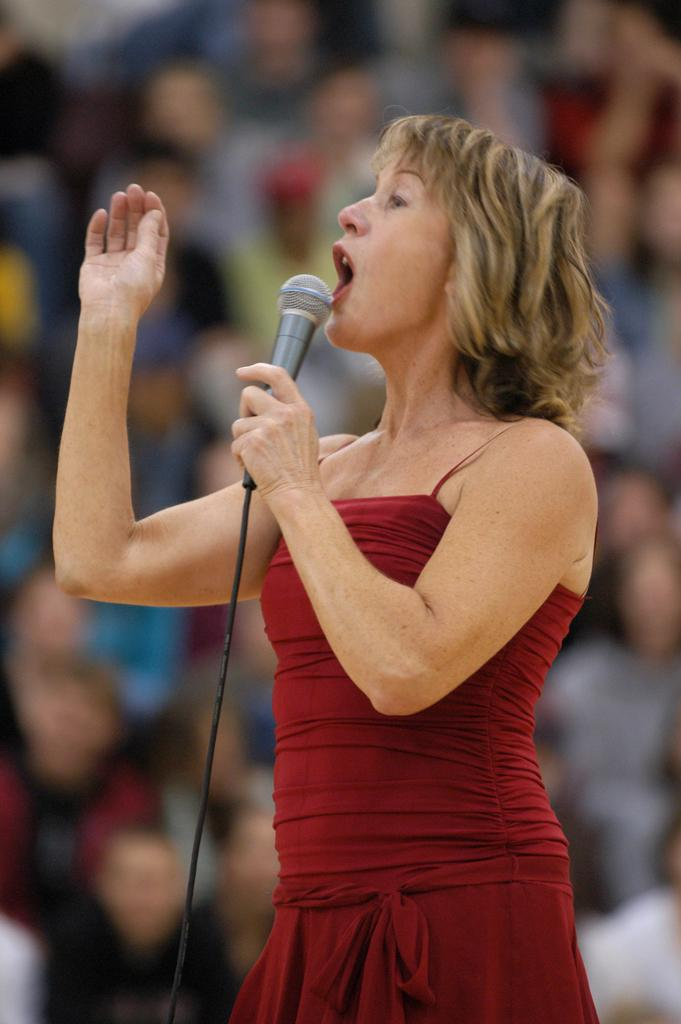Who is the main subject in the image? There is a woman in the image. What is the woman holding in her hand? The woman is holding a mic in her hand. What is the woman doing in the image? The woman is standing and talking. What are the people in the background doing? The people in the background are sitting and watching. What flavor of ice cream is the cow eating in the image? There is no cow or ice cream present in the image. How many cherries are on the woman's head in the image? There are no cherries on the woman's head in the image. 